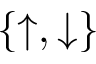<formula> <loc_0><loc_0><loc_500><loc_500>\{ \uparrow , \downarrow \}</formula> 